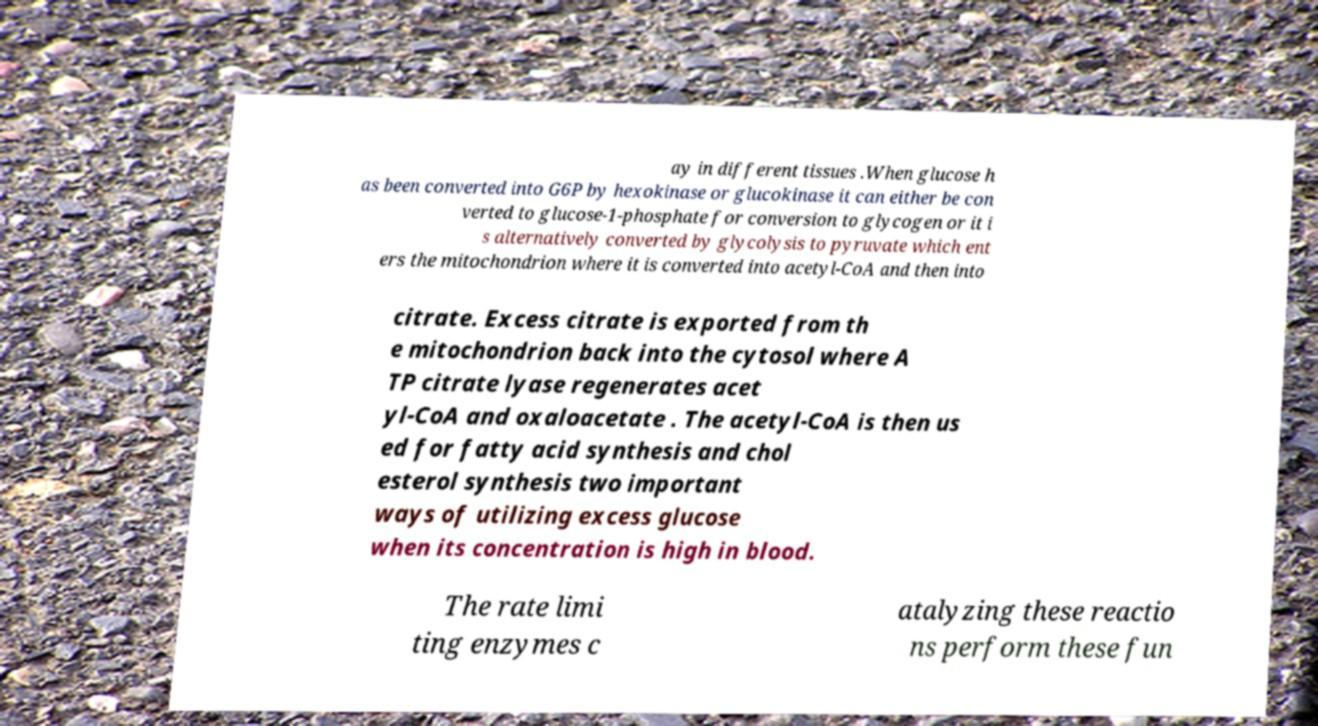Please identify and transcribe the text found in this image. ay in different tissues .When glucose h as been converted into G6P by hexokinase or glucokinase it can either be con verted to glucose-1-phosphate for conversion to glycogen or it i s alternatively converted by glycolysis to pyruvate which ent ers the mitochondrion where it is converted into acetyl-CoA and then into citrate. Excess citrate is exported from th e mitochondrion back into the cytosol where A TP citrate lyase regenerates acet yl-CoA and oxaloacetate . The acetyl-CoA is then us ed for fatty acid synthesis and chol esterol synthesis two important ways of utilizing excess glucose when its concentration is high in blood. The rate limi ting enzymes c atalyzing these reactio ns perform these fun 